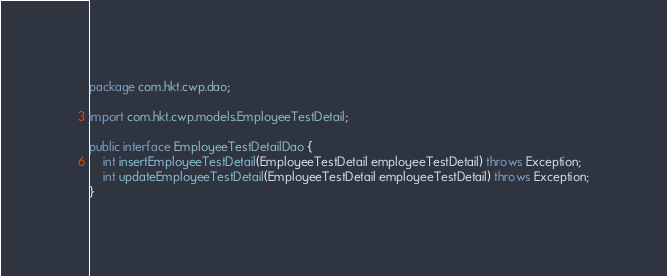Convert code to text. <code><loc_0><loc_0><loc_500><loc_500><_Java_>package com.hkt.cwp.dao;

import com.hkt.cwp.models.EmployeeTestDetail;

public interface EmployeeTestDetailDao {
	int insertEmployeeTestDetail(EmployeeTestDetail employeeTestDetail) throws Exception;
	int updateEmployeeTestDetail(EmployeeTestDetail employeeTestDetail) throws Exception;
}
</code> 